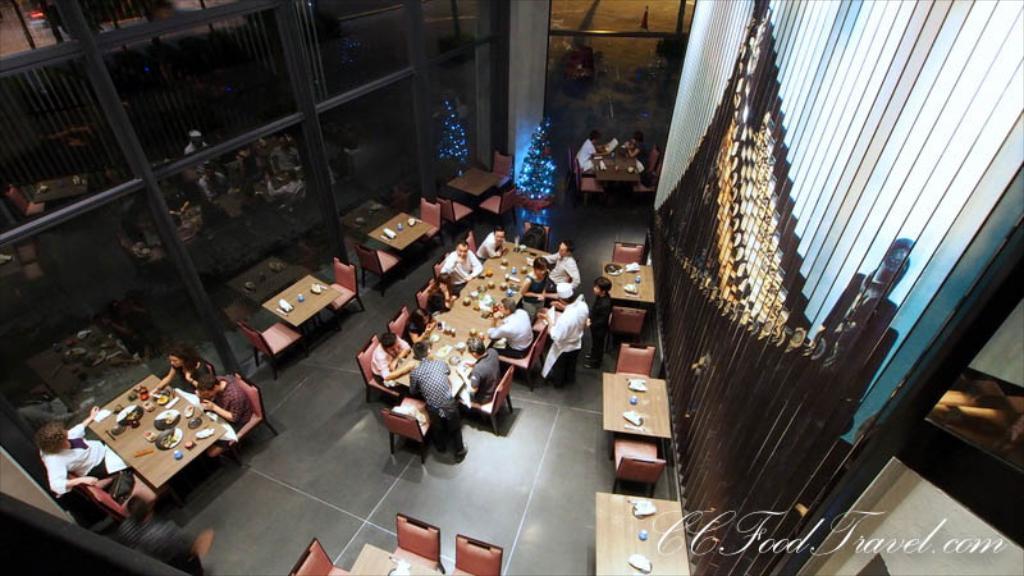In one or two sentences, can you explain what this image depicts? In this image we can see a few people, some of them are sitting, there are tables, chairs, few people are eating food, there are food items, paper napkins, bottles on the tables, there is a Christmas tree, there are serial lights on it, there is the wall with a design on it, also we can see all those reflections on the glass wall. 